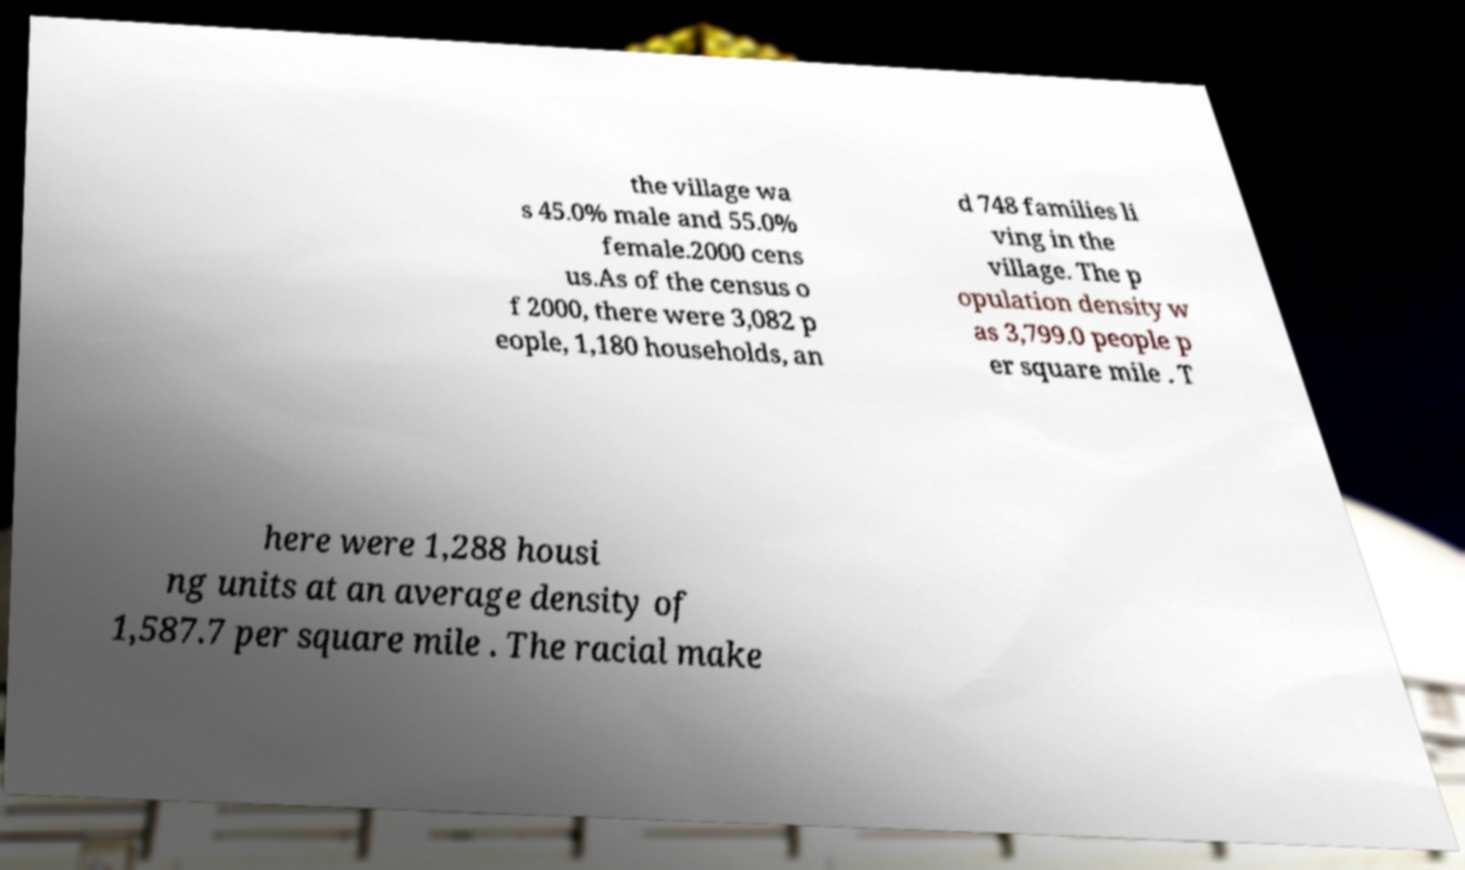What messages or text are displayed in this image? I need them in a readable, typed format. the village wa s 45.0% male and 55.0% female.2000 cens us.As of the census o f 2000, there were 3,082 p eople, 1,180 households, an d 748 families li ving in the village. The p opulation density w as 3,799.0 people p er square mile . T here were 1,288 housi ng units at an average density of 1,587.7 per square mile . The racial make 